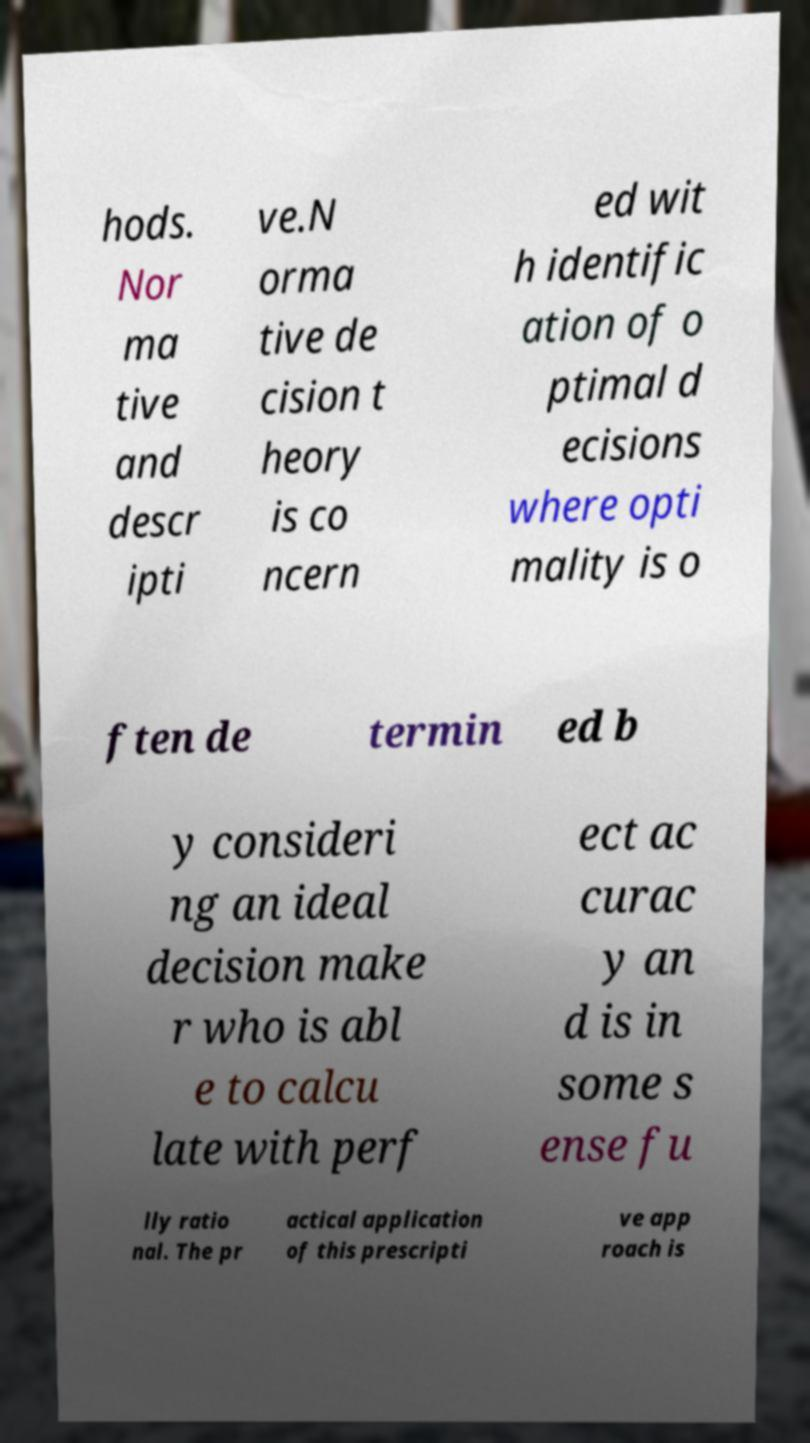Please identify and transcribe the text found in this image. hods. Nor ma tive and descr ipti ve.N orma tive de cision t heory is co ncern ed wit h identific ation of o ptimal d ecisions where opti mality is o ften de termin ed b y consideri ng an ideal decision make r who is abl e to calcu late with perf ect ac curac y an d is in some s ense fu lly ratio nal. The pr actical application of this prescripti ve app roach is 